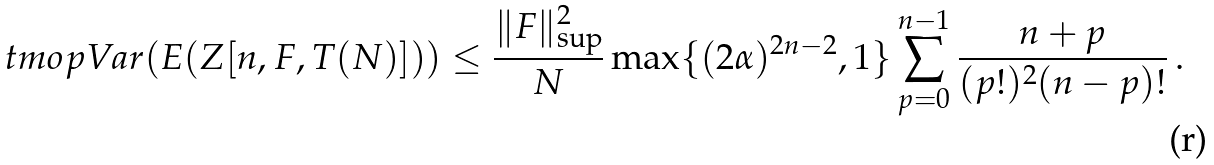Convert formula to latex. <formula><loc_0><loc_0><loc_500><loc_500>\ t m o p { V a r } ( E ( Z [ n , F , T ( N ) ] ) ) \leq \frac { \| F \| _ { \sup } ^ { 2 } } { N } \max \{ ( 2 \alpha ) ^ { 2 n - 2 } , 1 \} \sum _ { p = 0 } ^ { n - 1 } \frac { n + p } { ( p ! ) ^ { 2 } ( n - p ) ! } \, .</formula> 